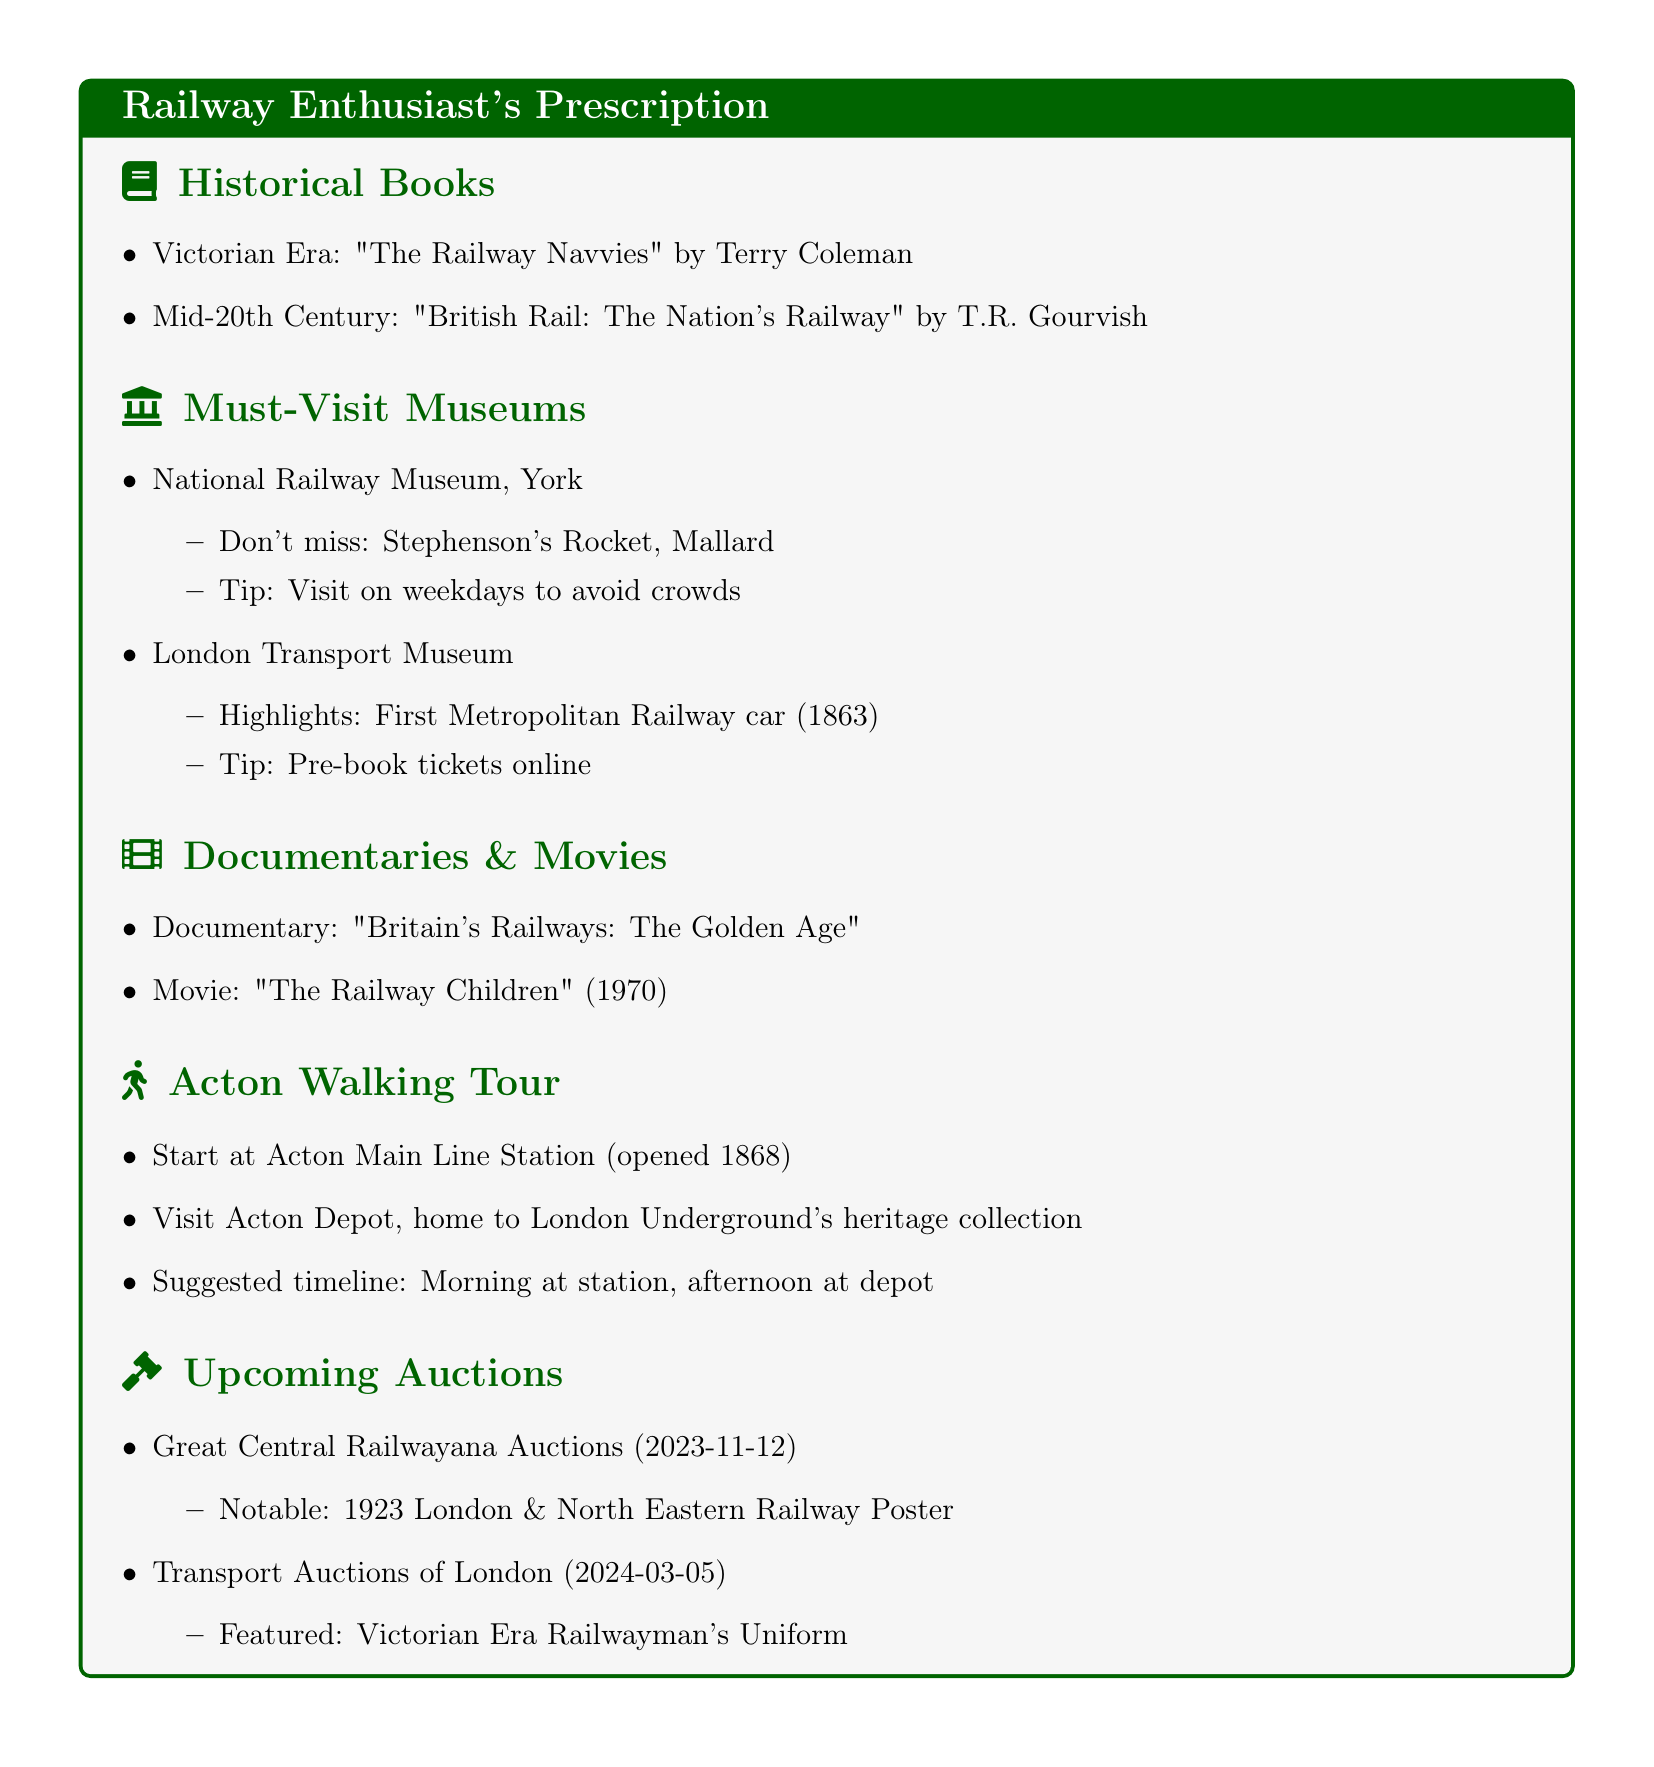What book covers the Victorian Era? The document lists "The Railway Navvies" by Terry Coleman as covering the Victorian Era.
Answer: The Railway Navvies Which museum features Stephenson's Rocket? The National Railway Museum in York is mentioned as featuring Stephenson's Rocket.
Answer: National Railway Museum What is suggested for visiting the London Transport Museum? The document advises to pre-book tickets online for visiting the London Transport Museum.
Answer: Pre-book tickets online What is the notable item at the Great Central Railwayana Auctions? The document mentions a 1923 London & North Eastern Railway Poster as a notable item at the auction.
Answer: 1923 London & North Eastern Railway Poster How many documentaries or movies are listed? The document lists one documentary and one movie, totaling two items.
Answer: Two 